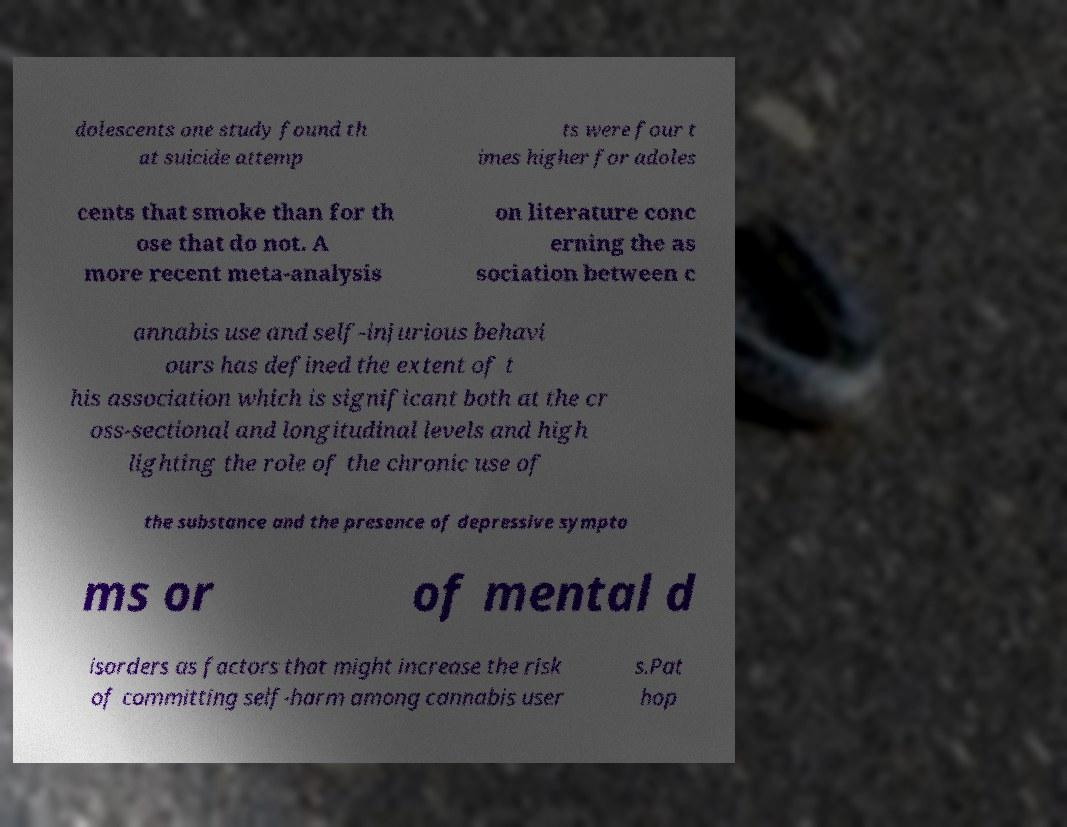Please identify and transcribe the text found in this image. dolescents one study found th at suicide attemp ts were four t imes higher for adoles cents that smoke than for th ose that do not. A more recent meta-analysis on literature conc erning the as sociation between c annabis use and self-injurious behavi ours has defined the extent of t his association which is significant both at the cr oss-sectional and longitudinal levels and high lighting the role of the chronic use of the substance and the presence of depressive sympto ms or of mental d isorders as factors that might increase the risk of committing self-harm among cannabis user s.Pat hop 